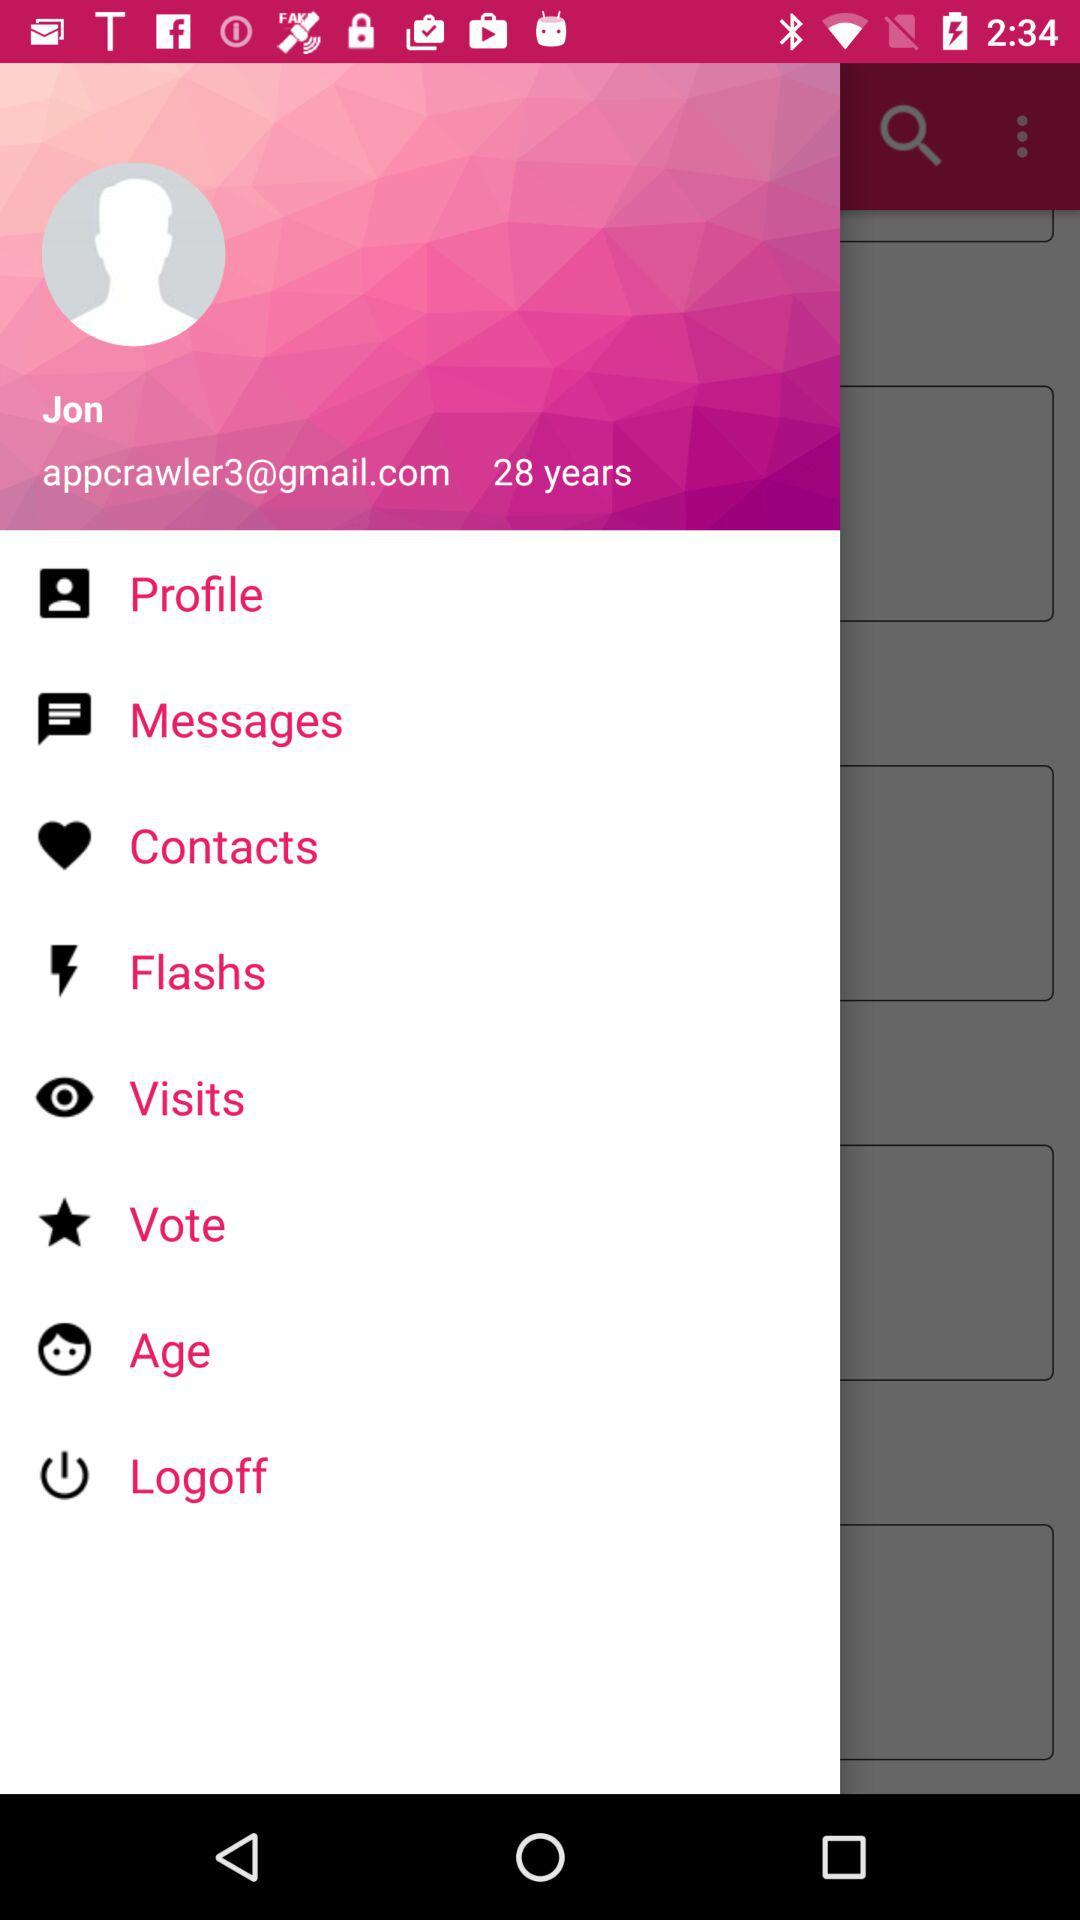What is the email address? The email address is appcrawler3@gmail.com. 